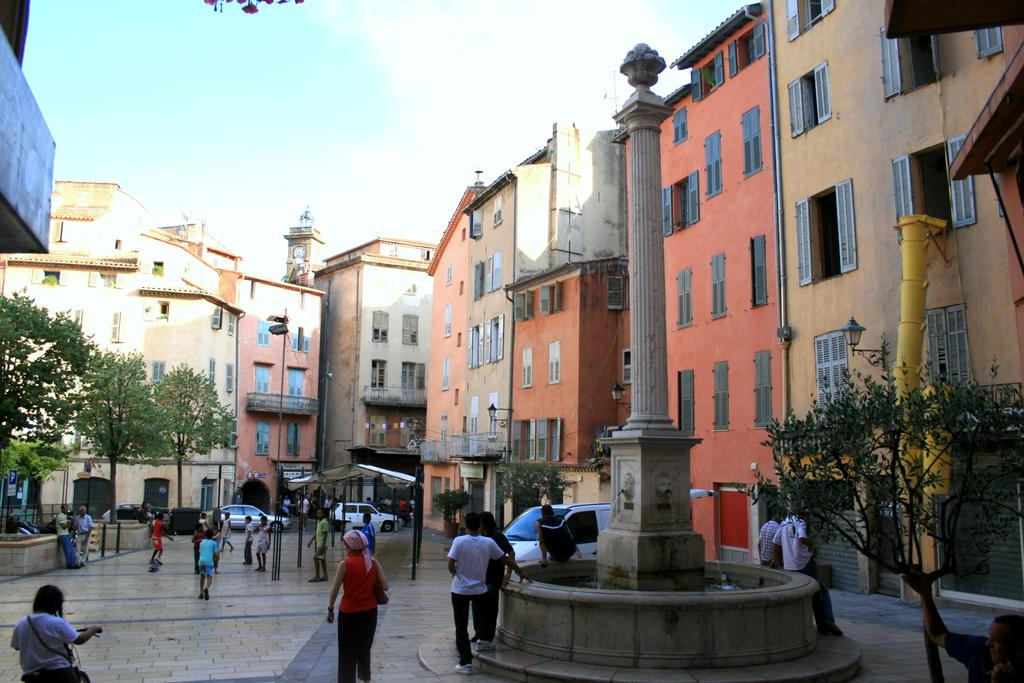What type of location is depicted in the image? The image depicts a city. Can you describe the people in the image? There are groups of people standing in the image. What structures can be seen in the image? There are buildings in the image. What else is present in the image besides people and buildings? Vehicles, pillars, poles, at least one light, trees, and the sky are visible in the image. What type of celery is being used as a decoration in the image? There is no celery present in the image; it is a city scene with people, buildings, vehicles, pillars, poles, lights, trees, and the sky. 